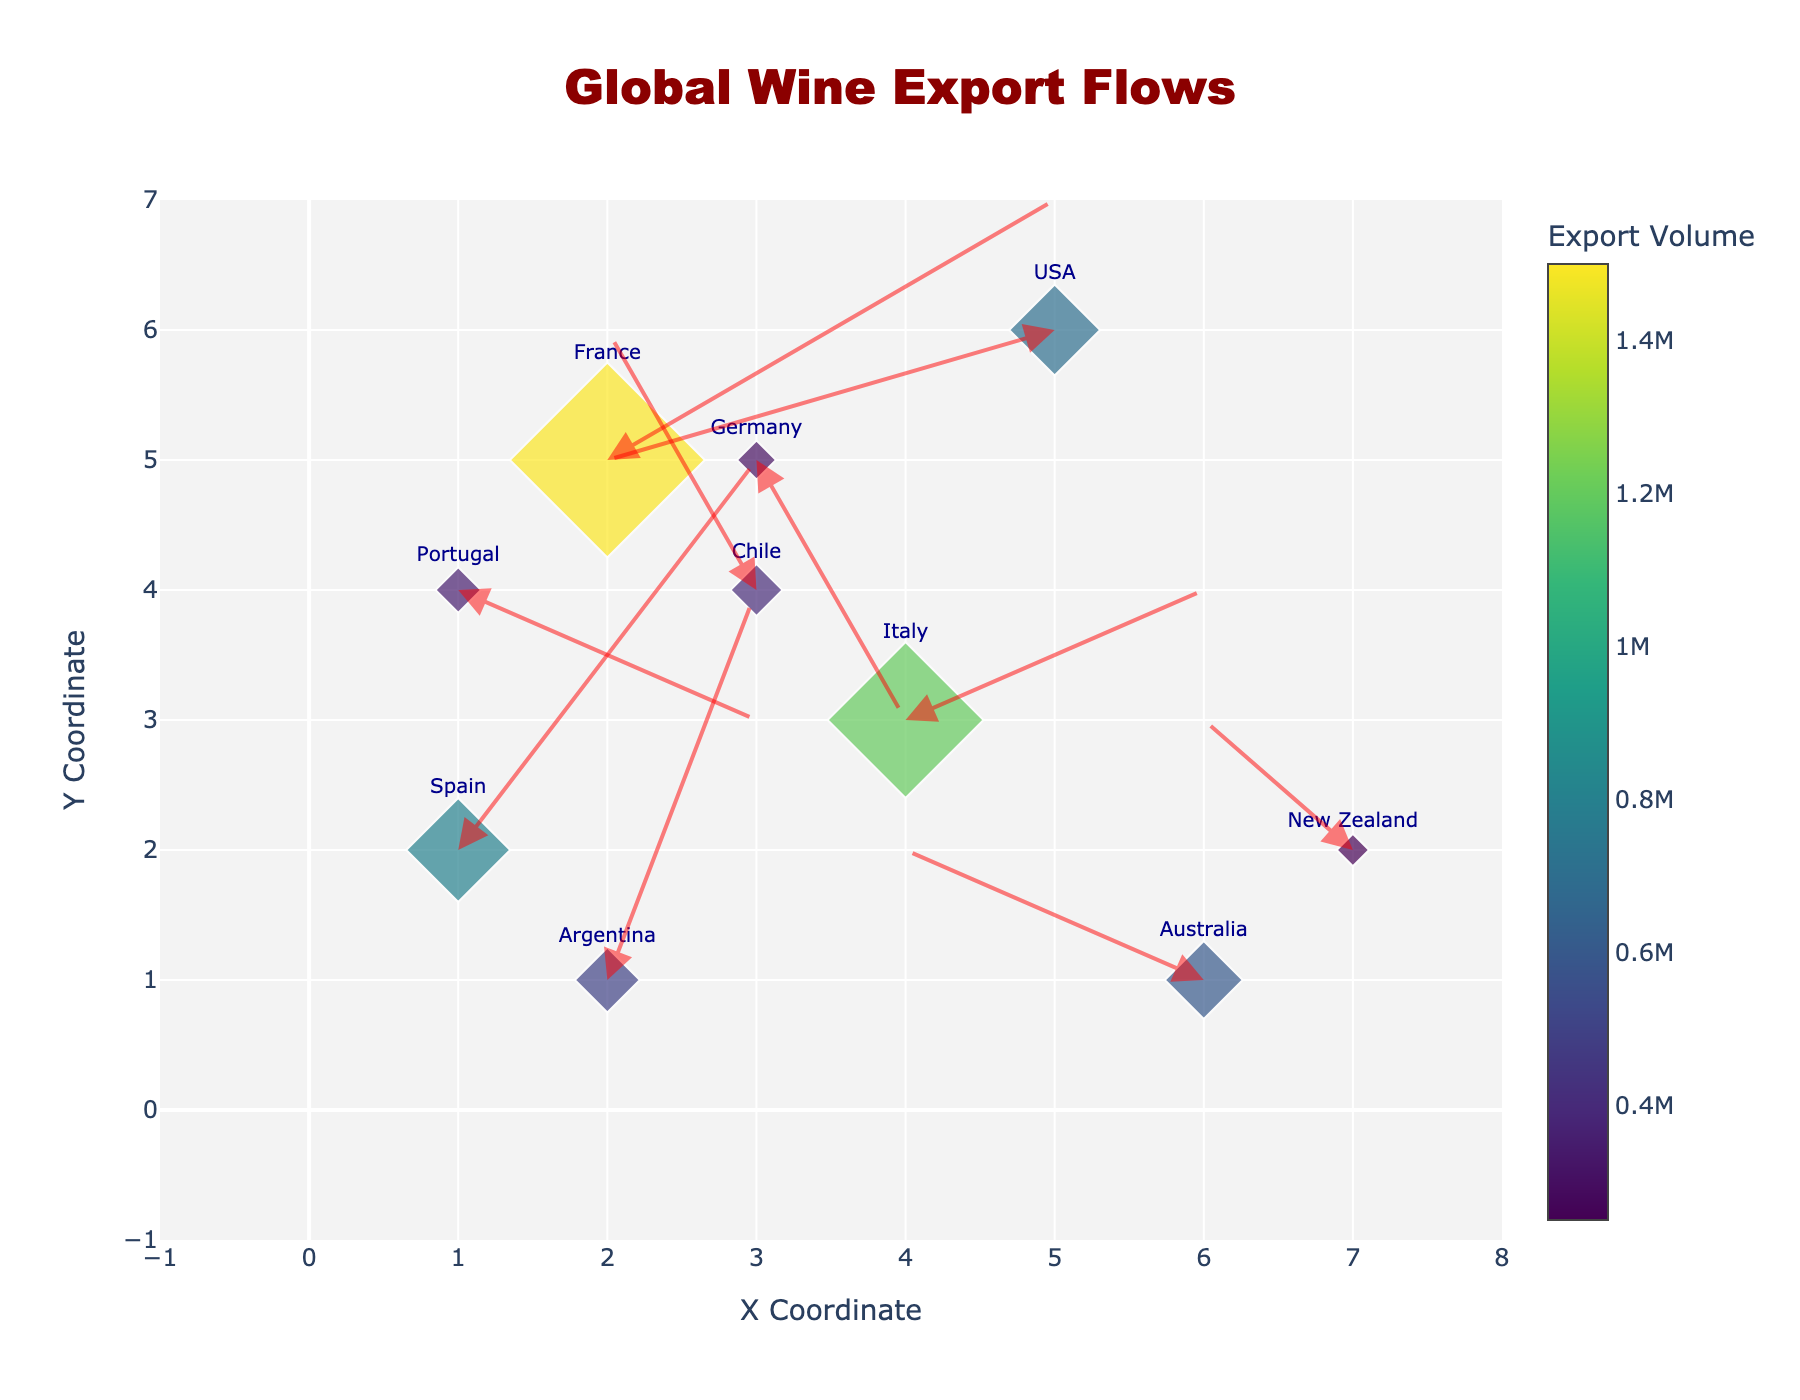How many countries are represented in the graph? By counting all the unique country names displayed on the plot, including France, Italy, Spain, Australia, Chile, USA, Germany, Argentina, New Zealand, and Portugal, we get a total.
Answer: 10 Which country exports the most wine by volume? The marker size is proportional to the export volume, and the colors also reflect this. The largest marker with the darkest color indicates France, which exports 1,500,000 units of wine.
Answer: France What is the general direction of wine exports from Australia? Observing the arrow originating from Australia's coordinates (6, 1), it points to the left (negative X direction) and slightly upwards (positive Y direction), indicating exports to the west and north.
Answer: West-north Which country has the smallest export volume, and what is it? By comparing the sizes and colors of the markers, the smallest marker with the lightest color corresponds to New Zealand, which exports 250,000 units of wine.
Answer: New Zealand, 250,000 How many countries have export arrows pointing in the negative X direction? By examining the arrows, we notice the negative X direction is indicated by arrows pointing left. These include Australia, Chile, and USA.
Answer: 3 What is the combined export volume of Italy and Spain? First, find the export volumes: Italy (1,200,000) and Spain (800,000). Add them together: 1,200,000 + 800,000.
Answer: 2,000,000 Compare the export volumes of Germany and Argentina; which country exports more? Check the size and color of Germany and Argentina markers. Germany exports 300,000, while Argentina exports 500,000. Argentina exports more.
Answer: Argentina Does any country export wine in a southeast direction? Arrows towards the bottom right indicate the southeast. None of the arrows in the plot points in this direction.
Answer: No Identify the country exporting wine to a west-southwest direction and name it. The west-southwest direction is indicated by arrows pointing left and down. The USA has an arrow pointing in this direction.
Answer: USA What can be concluded about wine export trends to the north based on the quiver plot? Arrows pointing upwards indicate northern direction exports. Countries exporting wine northward include Spain, Chile, and Argentina, showing a trend of wine flow to northern regions from these countries.
Answer: Spain, Chile, Argentina 